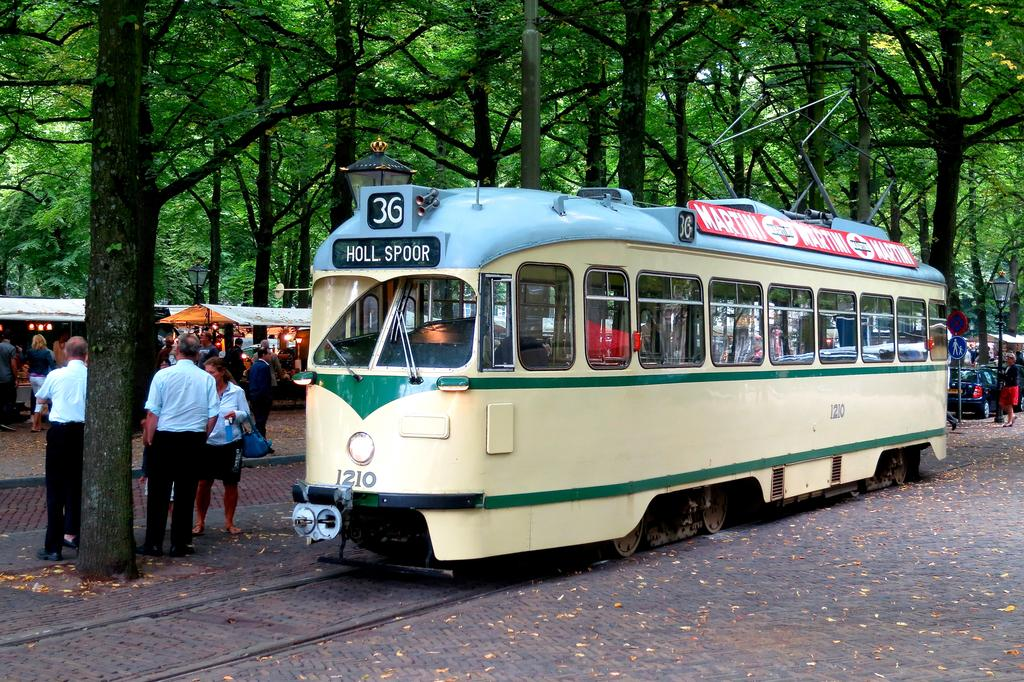What is the main subject of the image? The main subject of the image is a train on the track. Where are the people located in the image? The people are standing on the left side of the image. What type of natural scenery can be seen in the image? There are trees visible in the image. What other mode of transportation can be seen in the image? There is a car on the right side of the image. What type of jeans are the trees wearing in the image? Trees do not wear jeans, as they are not living beings capable of wearing clothing. 